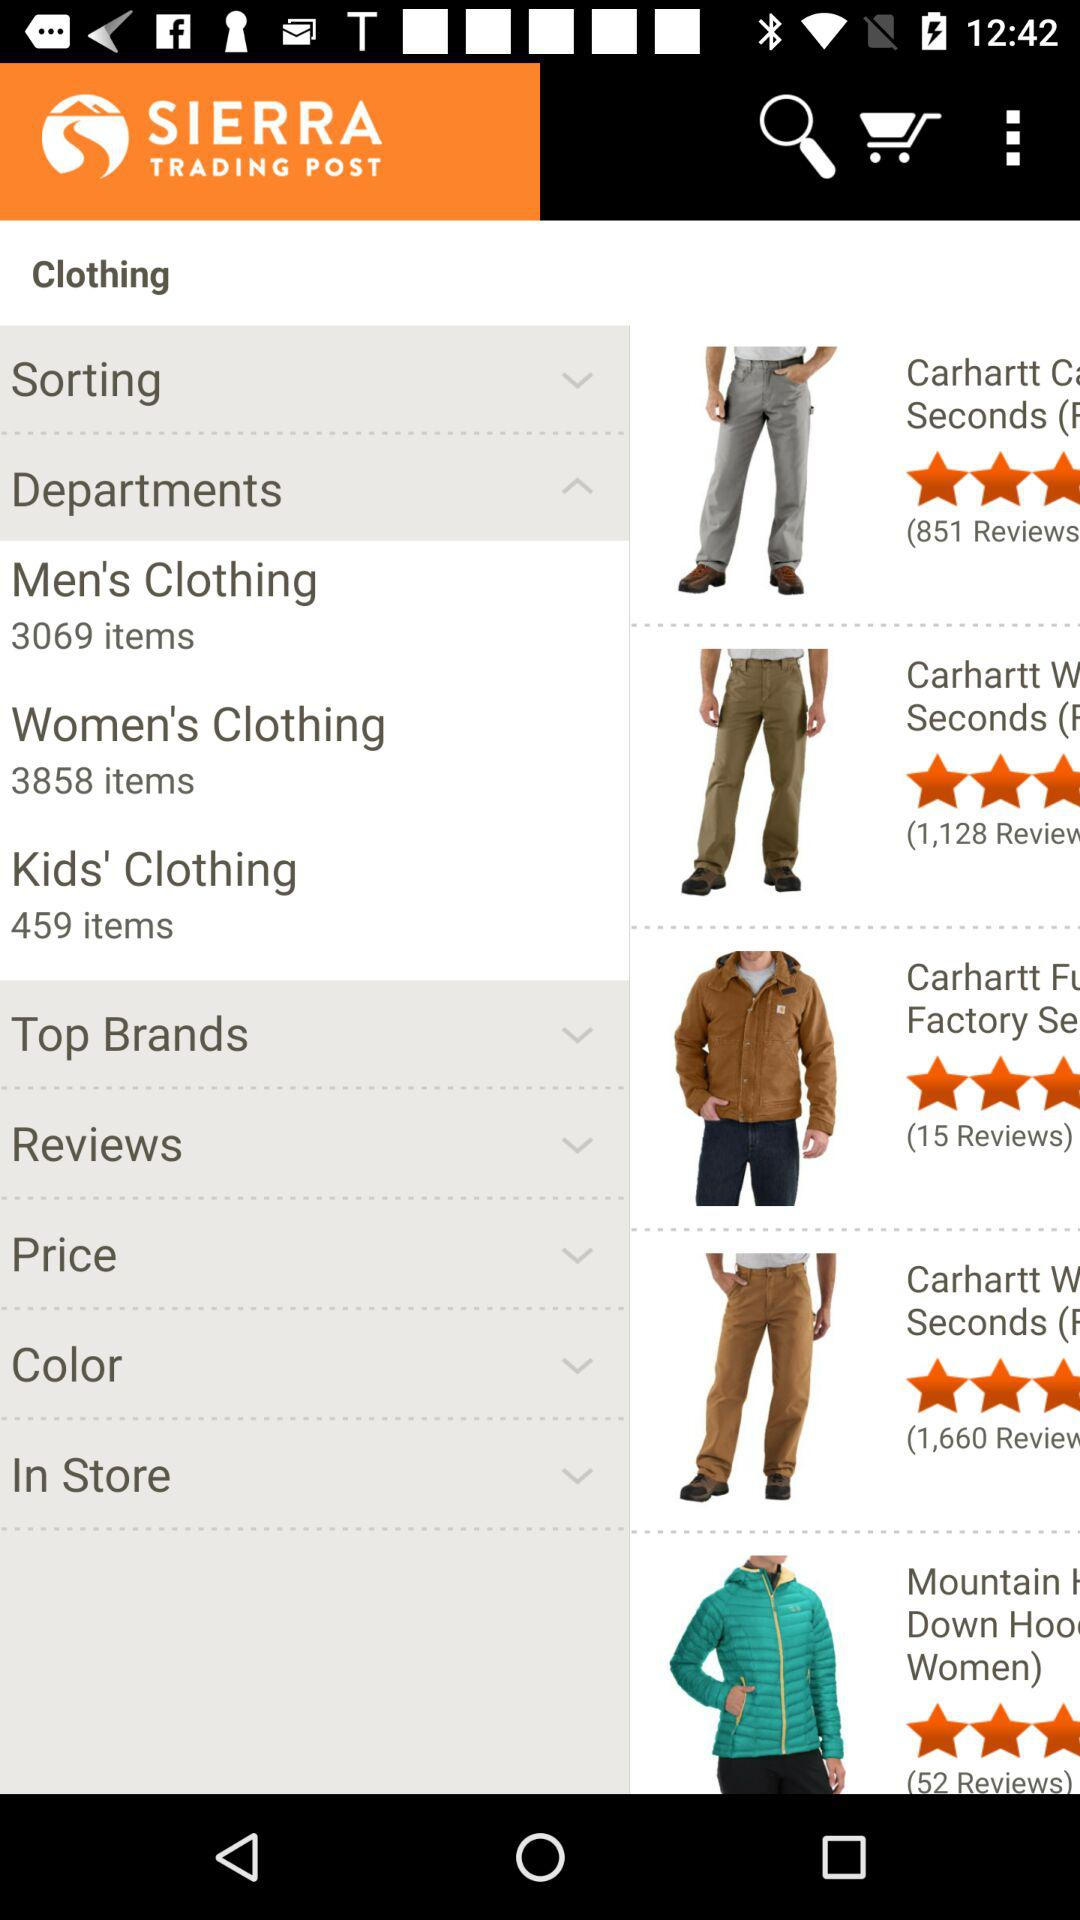How many items are there in the 'Kids' Clothing' department?
Answer the question using a single word or phrase. 459 